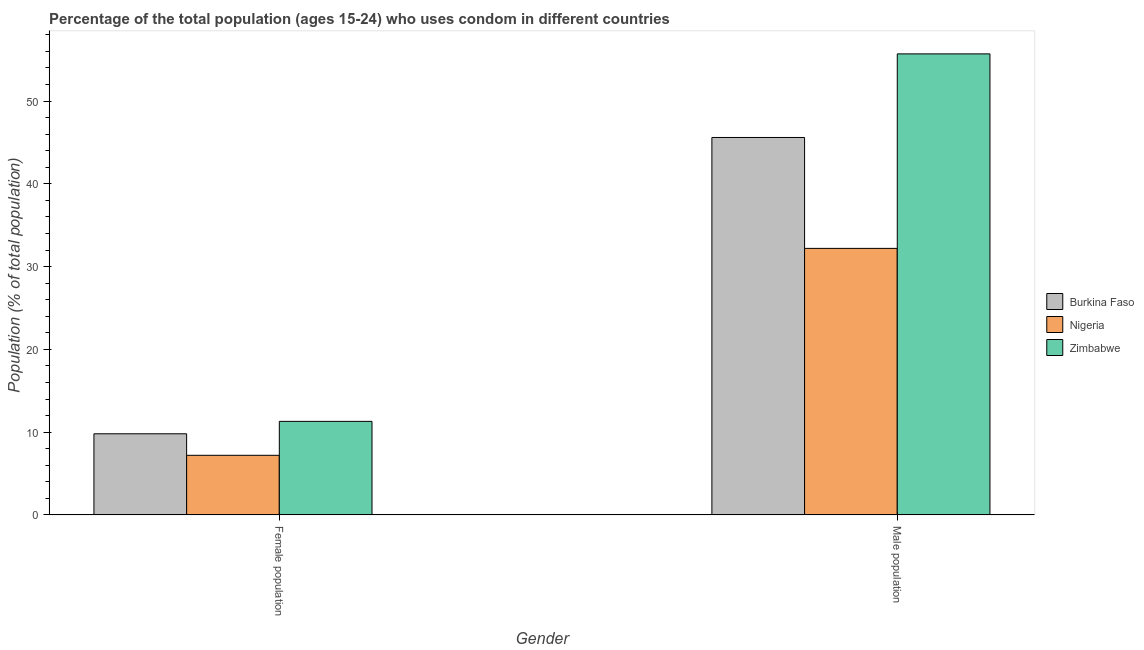How many bars are there on the 2nd tick from the left?
Keep it short and to the point. 3. How many bars are there on the 2nd tick from the right?
Make the answer very short. 3. What is the label of the 2nd group of bars from the left?
Make the answer very short. Male population. What is the male population in Zimbabwe?
Your response must be concise. 55.7. Across all countries, what is the minimum male population?
Your answer should be compact. 32.2. In which country was the male population maximum?
Ensure brevity in your answer.  Zimbabwe. In which country was the female population minimum?
Provide a short and direct response. Nigeria. What is the total female population in the graph?
Offer a terse response. 28.3. What is the difference between the male population in Burkina Faso and that in Nigeria?
Keep it short and to the point. 13.4. What is the difference between the female population in Zimbabwe and the male population in Burkina Faso?
Keep it short and to the point. -34.3. What is the average male population per country?
Provide a succinct answer. 44.5. What is the difference between the male population and female population in Nigeria?
Ensure brevity in your answer.  25. In how many countries, is the female population greater than 42 %?
Your answer should be very brief. 0. What is the ratio of the female population in Burkina Faso to that in Nigeria?
Offer a very short reply. 1.36. In how many countries, is the female population greater than the average female population taken over all countries?
Provide a succinct answer. 2. What does the 3rd bar from the left in Female population represents?
Make the answer very short. Zimbabwe. What does the 3rd bar from the right in Male population represents?
Your answer should be very brief. Burkina Faso. What is the difference between two consecutive major ticks on the Y-axis?
Your response must be concise. 10. Does the graph contain any zero values?
Your answer should be very brief. No. Does the graph contain grids?
Make the answer very short. No. How many legend labels are there?
Your response must be concise. 3. What is the title of the graph?
Your answer should be very brief. Percentage of the total population (ages 15-24) who uses condom in different countries. Does "Croatia" appear as one of the legend labels in the graph?
Your answer should be compact. No. What is the label or title of the Y-axis?
Your answer should be compact. Population (% of total population) . What is the Population (% of total population)  of Burkina Faso in Female population?
Provide a short and direct response. 9.8. What is the Population (% of total population)  of Nigeria in Female population?
Give a very brief answer. 7.2. What is the Population (% of total population)  of Burkina Faso in Male population?
Ensure brevity in your answer.  45.6. What is the Population (% of total population)  of Nigeria in Male population?
Give a very brief answer. 32.2. What is the Population (% of total population)  in Zimbabwe in Male population?
Provide a succinct answer. 55.7. Across all Gender, what is the maximum Population (% of total population)  in Burkina Faso?
Your answer should be very brief. 45.6. Across all Gender, what is the maximum Population (% of total population)  of Nigeria?
Your answer should be very brief. 32.2. Across all Gender, what is the maximum Population (% of total population)  in Zimbabwe?
Your response must be concise. 55.7. Across all Gender, what is the minimum Population (% of total population)  in Nigeria?
Your answer should be compact. 7.2. What is the total Population (% of total population)  of Burkina Faso in the graph?
Offer a very short reply. 55.4. What is the total Population (% of total population)  in Nigeria in the graph?
Keep it short and to the point. 39.4. What is the difference between the Population (% of total population)  of Burkina Faso in Female population and that in Male population?
Make the answer very short. -35.8. What is the difference between the Population (% of total population)  of Nigeria in Female population and that in Male population?
Give a very brief answer. -25. What is the difference between the Population (% of total population)  in Zimbabwe in Female population and that in Male population?
Provide a short and direct response. -44.4. What is the difference between the Population (% of total population)  of Burkina Faso in Female population and the Population (% of total population)  of Nigeria in Male population?
Keep it short and to the point. -22.4. What is the difference between the Population (% of total population)  in Burkina Faso in Female population and the Population (% of total population)  in Zimbabwe in Male population?
Your response must be concise. -45.9. What is the difference between the Population (% of total population)  of Nigeria in Female population and the Population (% of total population)  of Zimbabwe in Male population?
Give a very brief answer. -48.5. What is the average Population (% of total population)  in Burkina Faso per Gender?
Make the answer very short. 27.7. What is the average Population (% of total population)  of Nigeria per Gender?
Offer a very short reply. 19.7. What is the average Population (% of total population)  of Zimbabwe per Gender?
Your answer should be compact. 33.5. What is the difference between the Population (% of total population)  of Burkina Faso and Population (% of total population)  of Nigeria in Female population?
Offer a very short reply. 2.6. What is the difference between the Population (% of total population)  of Burkina Faso and Population (% of total population)  of Zimbabwe in Female population?
Offer a very short reply. -1.5. What is the difference between the Population (% of total population)  of Nigeria and Population (% of total population)  of Zimbabwe in Female population?
Your answer should be compact. -4.1. What is the difference between the Population (% of total population)  in Burkina Faso and Population (% of total population)  in Nigeria in Male population?
Give a very brief answer. 13.4. What is the difference between the Population (% of total population)  of Nigeria and Population (% of total population)  of Zimbabwe in Male population?
Your response must be concise. -23.5. What is the ratio of the Population (% of total population)  in Burkina Faso in Female population to that in Male population?
Your response must be concise. 0.21. What is the ratio of the Population (% of total population)  of Nigeria in Female population to that in Male population?
Your answer should be compact. 0.22. What is the ratio of the Population (% of total population)  of Zimbabwe in Female population to that in Male population?
Your answer should be compact. 0.2. What is the difference between the highest and the second highest Population (% of total population)  in Burkina Faso?
Make the answer very short. 35.8. What is the difference between the highest and the second highest Population (% of total population)  in Nigeria?
Offer a very short reply. 25. What is the difference between the highest and the second highest Population (% of total population)  of Zimbabwe?
Offer a terse response. 44.4. What is the difference between the highest and the lowest Population (% of total population)  in Burkina Faso?
Offer a very short reply. 35.8. What is the difference between the highest and the lowest Population (% of total population)  of Zimbabwe?
Your answer should be compact. 44.4. 